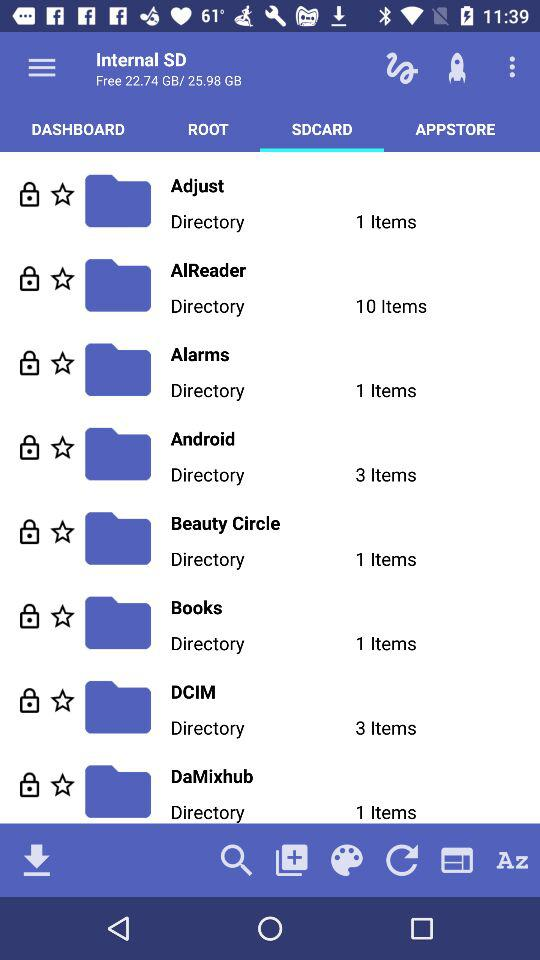What is the number of items in Android? The number of items is 3. 